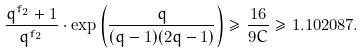Convert formula to latex. <formula><loc_0><loc_0><loc_500><loc_500>\frac { q ^ { f _ { 2 } } + 1 } { q ^ { f _ { 2 } } } \cdot \exp \left ( \frac { q } { ( q - 1 ) ( 2 q - 1 ) } \right ) \geq \frac { 1 6 } { 9 C } \geq 1 . 1 0 2 0 8 7 .</formula> 